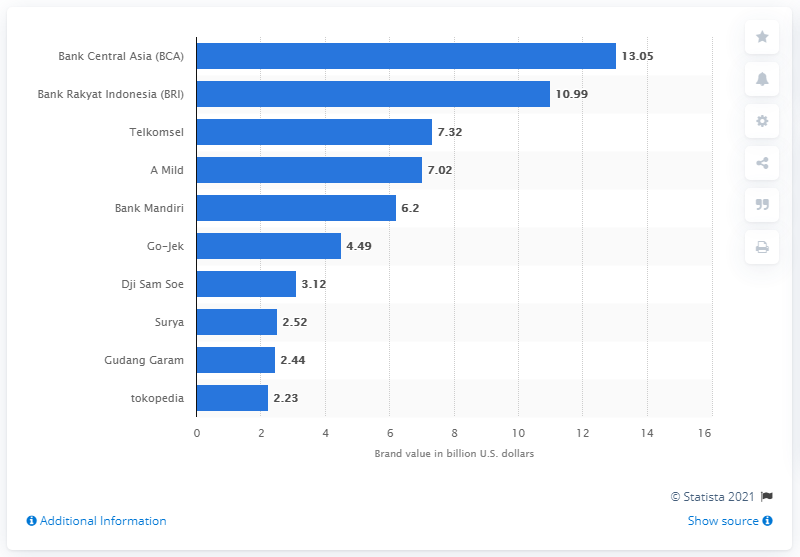Draw attention to some important aspects in this diagram. As of 2019, the brand value of Bank Central Asia was estimated to be 13.05 billion U.S. dollars. Go-Jek, a ride-hailing start-up, experienced an impressive 88 percent growth in 2019. In 2019, the fastest growing retail e-commerce site was Toptal. 